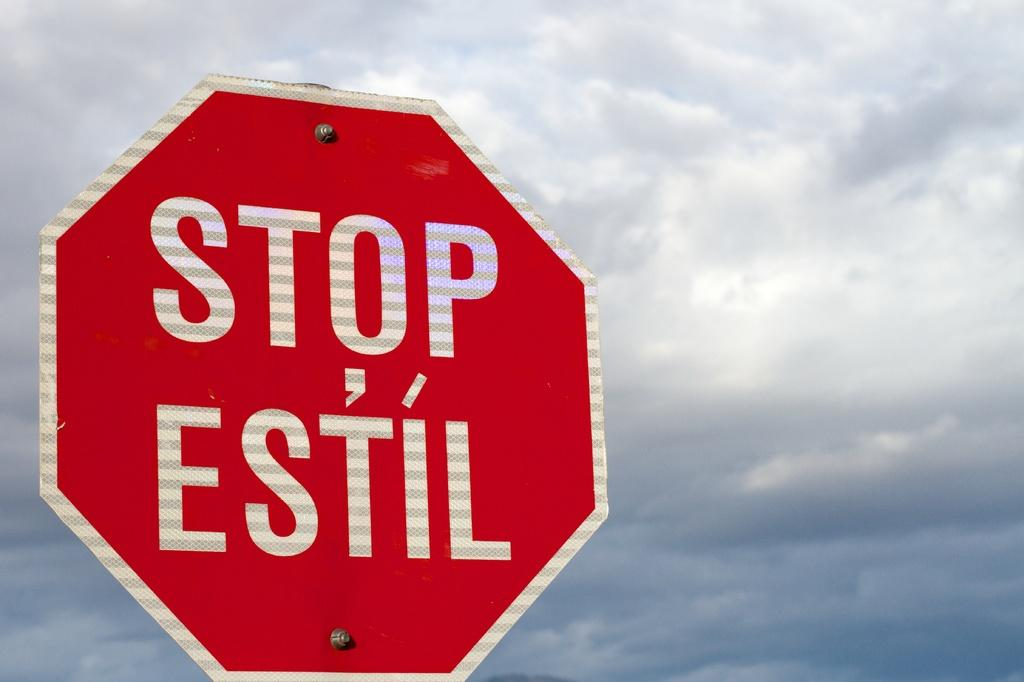<image>
Give a short and clear explanation of the subsequent image. a sign that says stop on it that is outside 